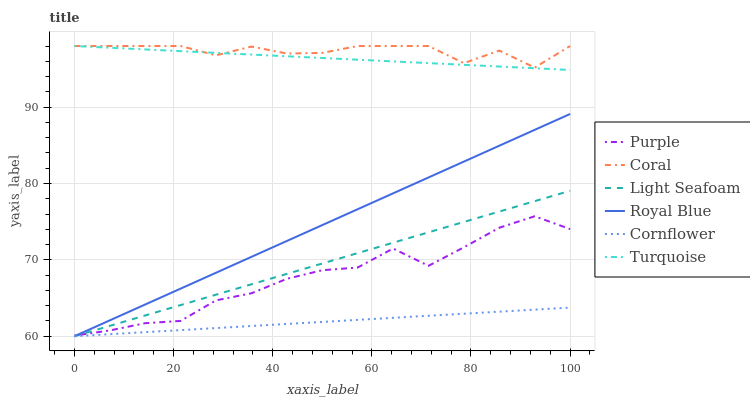Does Cornflower have the minimum area under the curve?
Answer yes or no. Yes. Does Coral have the maximum area under the curve?
Answer yes or no. Yes. Does Turquoise have the minimum area under the curve?
Answer yes or no. No. Does Turquoise have the maximum area under the curve?
Answer yes or no. No. Is Cornflower the smoothest?
Answer yes or no. Yes. Is Purple the roughest?
Answer yes or no. Yes. Is Turquoise the smoothest?
Answer yes or no. No. Is Turquoise the roughest?
Answer yes or no. No. Does Cornflower have the lowest value?
Answer yes or no. Yes. Does Turquoise have the lowest value?
Answer yes or no. No. Does Coral have the highest value?
Answer yes or no. Yes. Does Purple have the highest value?
Answer yes or no. No. Is Cornflower less than Purple?
Answer yes or no. Yes. Is Purple greater than Cornflower?
Answer yes or no. Yes. Does Light Seafoam intersect Purple?
Answer yes or no. Yes. Is Light Seafoam less than Purple?
Answer yes or no. No. Is Light Seafoam greater than Purple?
Answer yes or no. No. Does Cornflower intersect Purple?
Answer yes or no. No. 